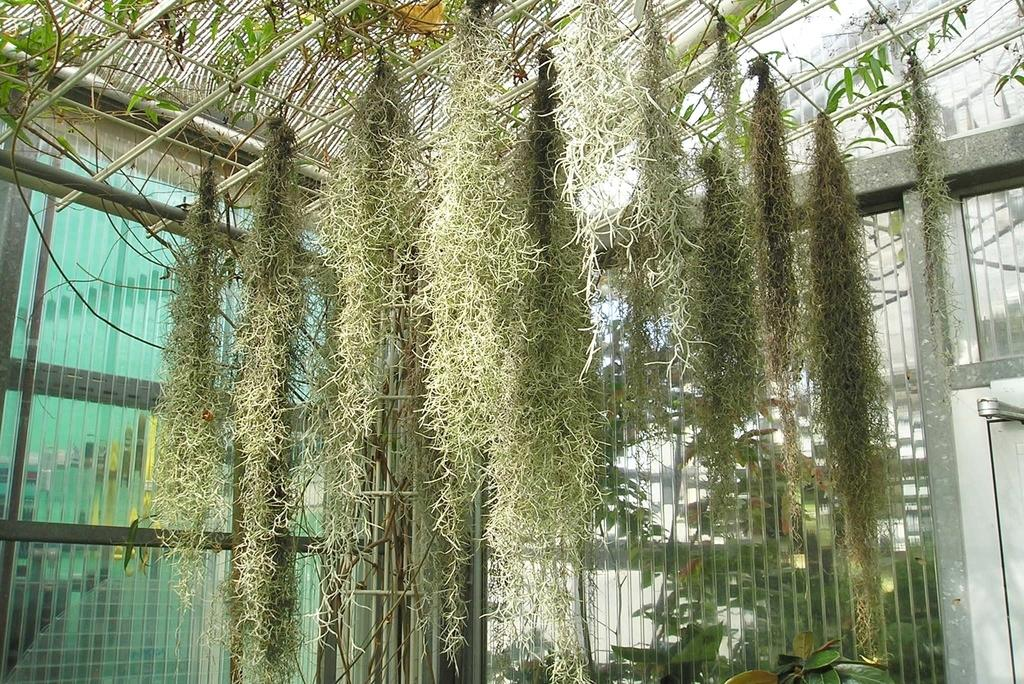What is located at the top of the image? There is a mesh at the top of the image. What type of plants are near the mesh? There are climber plants near the mesh. What can be seen in the background of the image? There are glass doors in the background of the image. What type of heart-shaped object can be seen on the mesh in the image? There is no heart-shaped object present on the mesh in the image. 